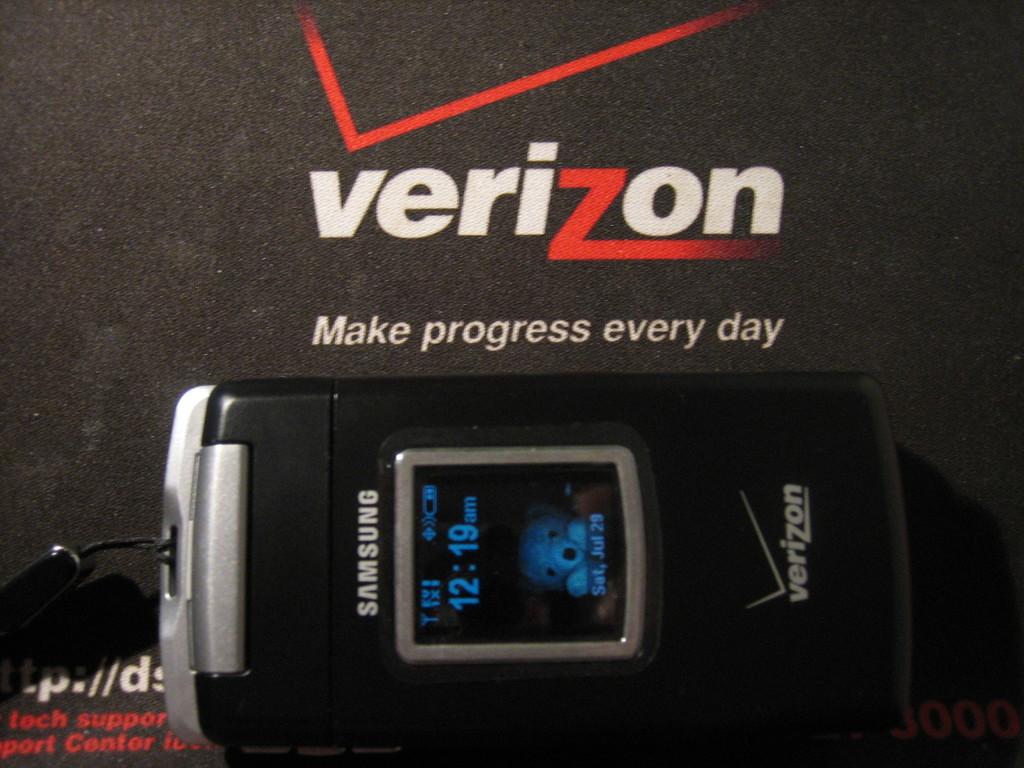Who is the carrier for the phone?
Offer a terse response. Verizon. What is made every day?
Offer a very short reply. Progress. 